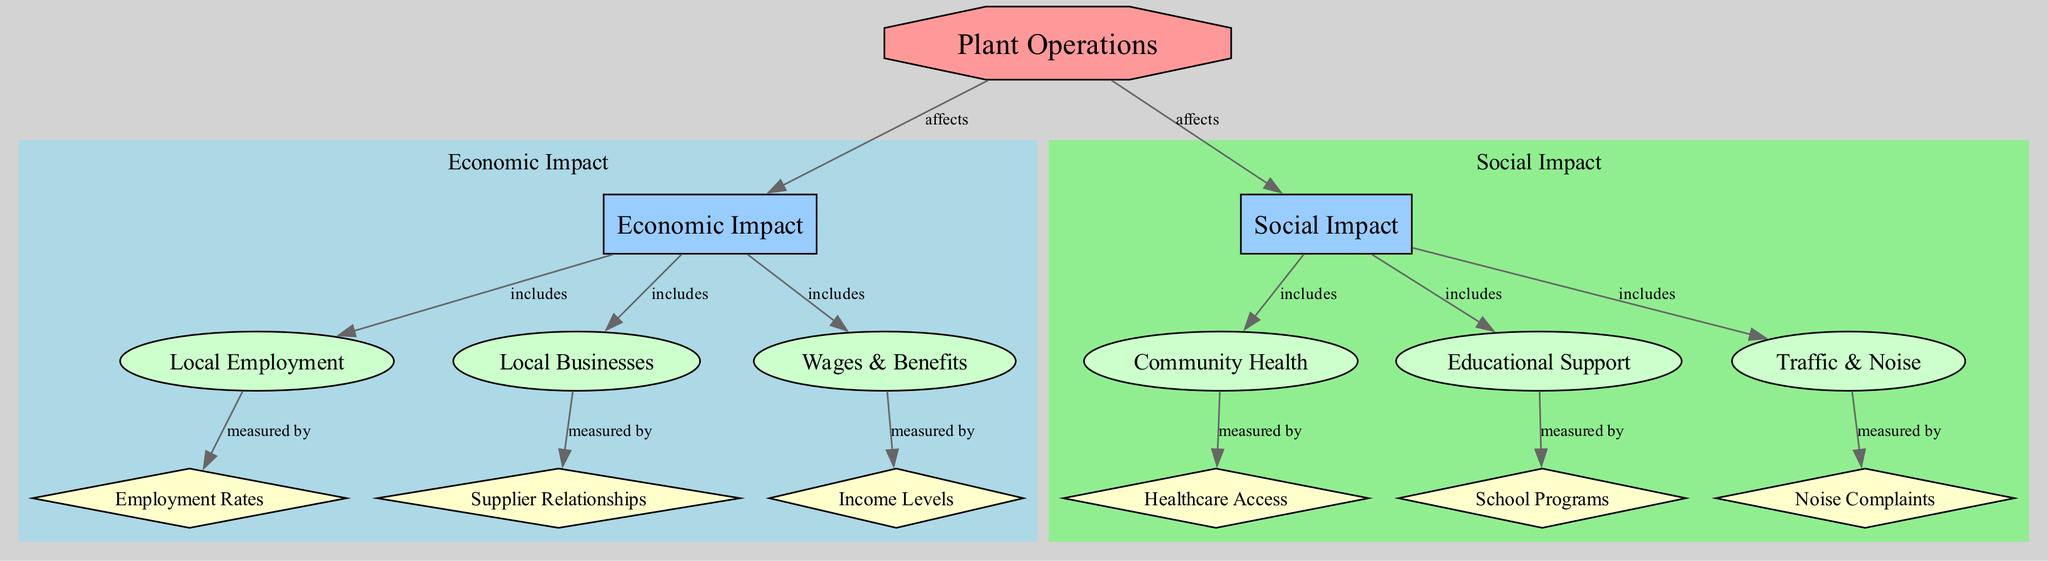What is the root node in the diagram? The root node represents the main subject or focus of the diagram. In this case, the node labeled "Plant Operations" is identified as the root node.
Answer: Plant Operations How many sub-categories are included under Economic Impact? There are three sub-categories listed under the Economic Impact category: Local Employment, Local Businesses, and Wages & Benefits.
Answer: 3 What relationship does the plant have with the Social Impact category? The diagram indicates that the "Plant Operations" is said to "affect" the Social Impact category, establishing a connection between them.
Answer: affects Which data is used to measure Local Employment? The Local Employment sub-category is measured by the Employment Rates data node, which provides a quantitative measure of employment within the community in relation to the plant's operations.
Answer: Employment Rates How does Community Health impact the data on Healthcare Access? Community Health includes the aspect of Healthcare Access, indicating that any changes or considerations regarding community health have a direct relationship affecting healthcare access within the local community.
Answer: includes What are the three types of impacts shown in the diagram? The three types of impacts identified in the diagram are Economic Impact, Social Impact, and the relationship stemming from Plant Operations affecting both.
Answer: Economic Impact, Social Impact What kind of measurement is associated with Noise Complaints? Noise Complaints, categorized under Social Impact, is measured by its corresponding data node, indicating community feedback and issues related to noise generated from Plant Operations.
Answer: measured by Which data is related to Local Businesses? The data node concerning Local Businesses is represented by Supplier Relationships, which signifies the economic ties and interactions between the plant and local business entities.
Answer: Supplier Relationships What visual style is used for the nodes under the category "Social Impact"? The nodes under the Social Impact category are displayed in an ellipse shape with a filled green color, which visually distinguishes them from other categories in the diagram.
Answer: ellipse shape, filled green color 